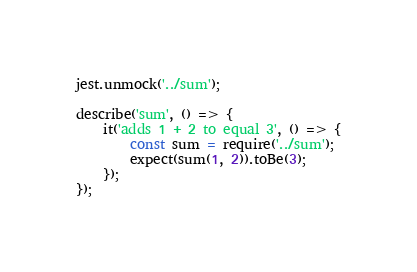<code> <loc_0><loc_0><loc_500><loc_500><_JavaScript_>jest.unmock('../sum');

describe('sum', () => {
    it('adds 1 + 2 to equal 3', () => {
        const sum = require('../sum');
        expect(sum(1, 2)).toBe(3);
    });
});
</code> 